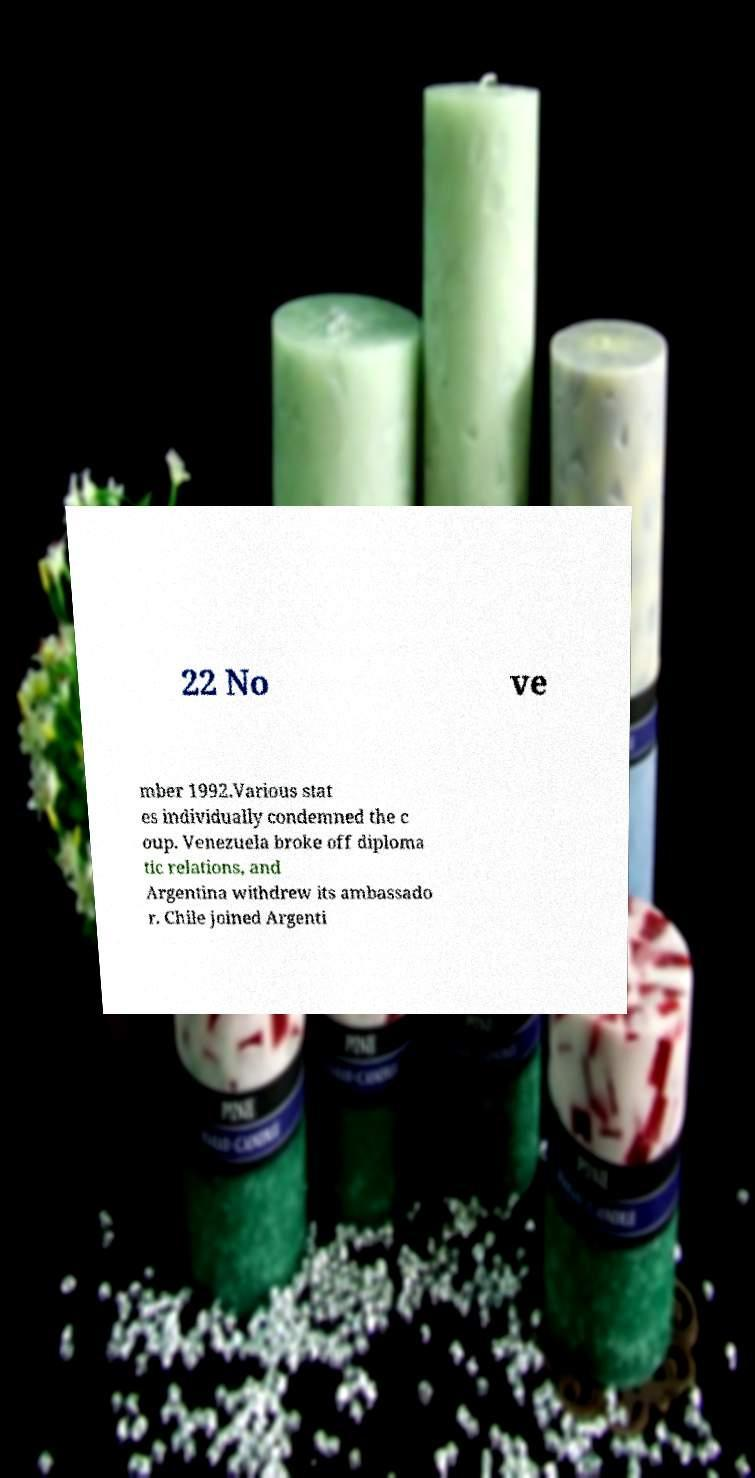Could you assist in decoding the text presented in this image and type it out clearly? 22 No ve mber 1992.Various stat es individually condemned the c oup. Venezuela broke off diploma tic relations, and Argentina withdrew its ambassado r. Chile joined Argenti 